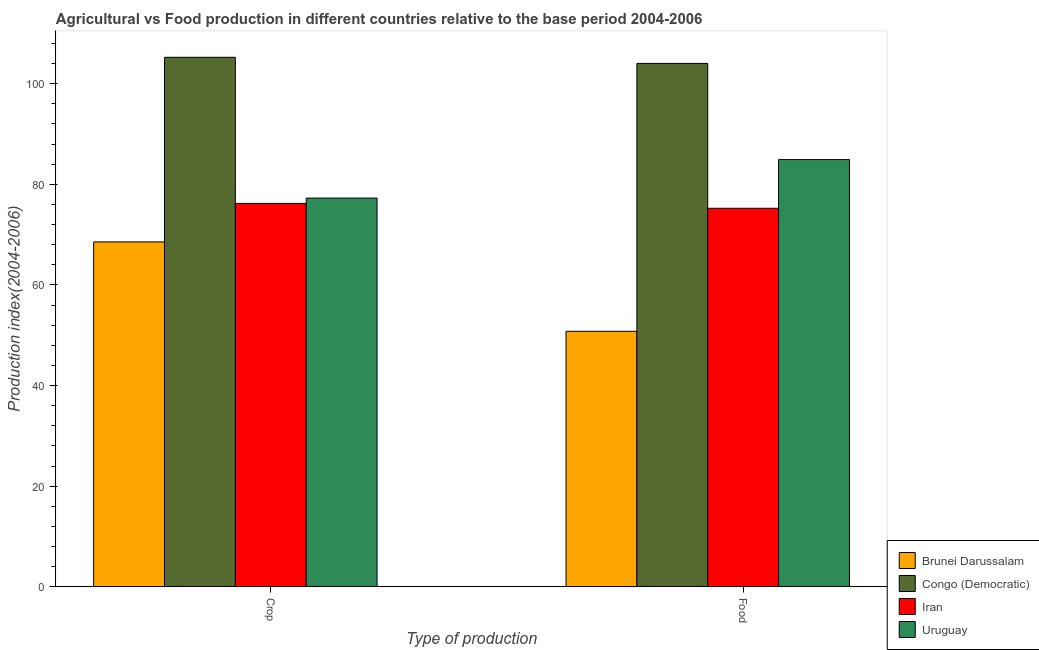Are the number of bars per tick equal to the number of legend labels?
Ensure brevity in your answer.  Yes. What is the label of the 2nd group of bars from the left?
Keep it short and to the point. Food. What is the crop production index in Iran?
Offer a terse response. 76.2. Across all countries, what is the maximum food production index?
Provide a succinct answer. 104.03. Across all countries, what is the minimum food production index?
Ensure brevity in your answer.  50.78. In which country was the crop production index maximum?
Your response must be concise. Congo (Democratic). In which country was the crop production index minimum?
Provide a succinct answer. Brunei Darussalam. What is the total crop production index in the graph?
Make the answer very short. 327.24. What is the difference between the crop production index in Iran and that in Congo (Democratic)?
Offer a terse response. -29.04. What is the difference between the crop production index in Congo (Democratic) and the food production index in Uruguay?
Give a very brief answer. 20.33. What is the average food production index per country?
Your response must be concise. 78.74. What is the difference between the crop production index and food production index in Uruguay?
Provide a short and direct response. -7.65. What is the ratio of the crop production index in Iran to that in Brunei Darussalam?
Your response must be concise. 1.11. What does the 4th bar from the left in Crop represents?
Provide a short and direct response. Uruguay. What does the 3rd bar from the right in Food represents?
Make the answer very short. Congo (Democratic). How many bars are there?
Offer a terse response. 8. Are all the bars in the graph horizontal?
Ensure brevity in your answer.  No. How many countries are there in the graph?
Your answer should be very brief. 4. Are the values on the major ticks of Y-axis written in scientific E-notation?
Provide a short and direct response. No. Where does the legend appear in the graph?
Ensure brevity in your answer.  Bottom right. How many legend labels are there?
Your response must be concise. 4. How are the legend labels stacked?
Provide a short and direct response. Vertical. What is the title of the graph?
Give a very brief answer. Agricultural vs Food production in different countries relative to the base period 2004-2006. What is the label or title of the X-axis?
Make the answer very short. Type of production. What is the label or title of the Y-axis?
Offer a terse response. Production index(2004-2006). What is the Production index(2004-2006) of Brunei Darussalam in Crop?
Offer a very short reply. 68.54. What is the Production index(2004-2006) of Congo (Democratic) in Crop?
Provide a short and direct response. 105.24. What is the Production index(2004-2006) in Iran in Crop?
Offer a very short reply. 76.2. What is the Production index(2004-2006) in Uruguay in Crop?
Give a very brief answer. 77.26. What is the Production index(2004-2006) of Brunei Darussalam in Food?
Your response must be concise. 50.78. What is the Production index(2004-2006) in Congo (Democratic) in Food?
Provide a short and direct response. 104.03. What is the Production index(2004-2006) of Iran in Food?
Offer a terse response. 75.23. What is the Production index(2004-2006) in Uruguay in Food?
Provide a succinct answer. 84.91. Across all Type of production, what is the maximum Production index(2004-2006) of Brunei Darussalam?
Provide a short and direct response. 68.54. Across all Type of production, what is the maximum Production index(2004-2006) of Congo (Democratic)?
Make the answer very short. 105.24. Across all Type of production, what is the maximum Production index(2004-2006) of Iran?
Ensure brevity in your answer.  76.2. Across all Type of production, what is the maximum Production index(2004-2006) in Uruguay?
Provide a short and direct response. 84.91. Across all Type of production, what is the minimum Production index(2004-2006) in Brunei Darussalam?
Your answer should be compact. 50.78. Across all Type of production, what is the minimum Production index(2004-2006) in Congo (Democratic)?
Provide a succinct answer. 104.03. Across all Type of production, what is the minimum Production index(2004-2006) in Iran?
Keep it short and to the point. 75.23. Across all Type of production, what is the minimum Production index(2004-2006) of Uruguay?
Give a very brief answer. 77.26. What is the total Production index(2004-2006) of Brunei Darussalam in the graph?
Your response must be concise. 119.32. What is the total Production index(2004-2006) in Congo (Democratic) in the graph?
Provide a succinct answer. 209.27. What is the total Production index(2004-2006) in Iran in the graph?
Your answer should be very brief. 151.43. What is the total Production index(2004-2006) of Uruguay in the graph?
Offer a very short reply. 162.17. What is the difference between the Production index(2004-2006) in Brunei Darussalam in Crop and that in Food?
Your response must be concise. 17.76. What is the difference between the Production index(2004-2006) in Congo (Democratic) in Crop and that in Food?
Your answer should be compact. 1.21. What is the difference between the Production index(2004-2006) of Uruguay in Crop and that in Food?
Provide a short and direct response. -7.65. What is the difference between the Production index(2004-2006) in Brunei Darussalam in Crop and the Production index(2004-2006) in Congo (Democratic) in Food?
Provide a succinct answer. -35.49. What is the difference between the Production index(2004-2006) in Brunei Darussalam in Crop and the Production index(2004-2006) in Iran in Food?
Offer a very short reply. -6.69. What is the difference between the Production index(2004-2006) of Brunei Darussalam in Crop and the Production index(2004-2006) of Uruguay in Food?
Make the answer very short. -16.37. What is the difference between the Production index(2004-2006) in Congo (Democratic) in Crop and the Production index(2004-2006) in Iran in Food?
Give a very brief answer. 30.01. What is the difference between the Production index(2004-2006) in Congo (Democratic) in Crop and the Production index(2004-2006) in Uruguay in Food?
Provide a short and direct response. 20.33. What is the difference between the Production index(2004-2006) of Iran in Crop and the Production index(2004-2006) of Uruguay in Food?
Your answer should be compact. -8.71. What is the average Production index(2004-2006) of Brunei Darussalam per Type of production?
Keep it short and to the point. 59.66. What is the average Production index(2004-2006) of Congo (Democratic) per Type of production?
Your response must be concise. 104.64. What is the average Production index(2004-2006) in Iran per Type of production?
Your response must be concise. 75.72. What is the average Production index(2004-2006) of Uruguay per Type of production?
Provide a short and direct response. 81.08. What is the difference between the Production index(2004-2006) in Brunei Darussalam and Production index(2004-2006) in Congo (Democratic) in Crop?
Provide a succinct answer. -36.7. What is the difference between the Production index(2004-2006) in Brunei Darussalam and Production index(2004-2006) in Iran in Crop?
Give a very brief answer. -7.66. What is the difference between the Production index(2004-2006) in Brunei Darussalam and Production index(2004-2006) in Uruguay in Crop?
Offer a very short reply. -8.72. What is the difference between the Production index(2004-2006) of Congo (Democratic) and Production index(2004-2006) of Iran in Crop?
Offer a very short reply. 29.04. What is the difference between the Production index(2004-2006) of Congo (Democratic) and Production index(2004-2006) of Uruguay in Crop?
Your answer should be very brief. 27.98. What is the difference between the Production index(2004-2006) of Iran and Production index(2004-2006) of Uruguay in Crop?
Provide a short and direct response. -1.06. What is the difference between the Production index(2004-2006) in Brunei Darussalam and Production index(2004-2006) in Congo (Democratic) in Food?
Your response must be concise. -53.25. What is the difference between the Production index(2004-2006) of Brunei Darussalam and Production index(2004-2006) of Iran in Food?
Offer a terse response. -24.45. What is the difference between the Production index(2004-2006) in Brunei Darussalam and Production index(2004-2006) in Uruguay in Food?
Your answer should be compact. -34.13. What is the difference between the Production index(2004-2006) in Congo (Democratic) and Production index(2004-2006) in Iran in Food?
Offer a terse response. 28.8. What is the difference between the Production index(2004-2006) in Congo (Democratic) and Production index(2004-2006) in Uruguay in Food?
Give a very brief answer. 19.12. What is the difference between the Production index(2004-2006) of Iran and Production index(2004-2006) of Uruguay in Food?
Keep it short and to the point. -9.68. What is the ratio of the Production index(2004-2006) in Brunei Darussalam in Crop to that in Food?
Your response must be concise. 1.35. What is the ratio of the Production index(2004-2006) of Congo (Democratic) in Crop to that in Food?
Offer a terse response. 1.01. What is the ratio of the Production index(2004-2006) in Iran in Crop to that in Food?
Offer a very short reply. 1.01. What is the ratio of the Production index(2004-2006) in Uruguay in Crop to that in Food?
Provide a short and direct response. 0.91. What is the difference between the highest and the second highest Production index(2004-2006) in Brunei Darussalam?
Make the answer very short. 17.76. What is the difference between the highest and the second highest Production index(2004-2006) in Congo (Democratic)?
Give a very brief answer. 1.21. What is the difference between the highest and the second highest Production index(2004-2006) in Iran?
Your response must be concise. 0.97. What is the difference between the highest and the second highest Production index(2004-2006) of Uruguay?
Provide a short and direct response. 7.65. What is the difference between the highest and the lowest Production index(2004-2006) in Brunei Darussalam?
Give a very brief answer. 17.76. What is the difference between the highest and the lowest Production index(2004-2006) of Congo (Democratic)?
Your answer should be very brief. 1.21. What is the difference between the highest and the lowest Production index(2004-2006) of Iran?
Give a very brief answer. 0.97. What is the difference between the highest and the lowest Production index(2004-2006) in Uruguay?
Your response must be concise. 7.65. 